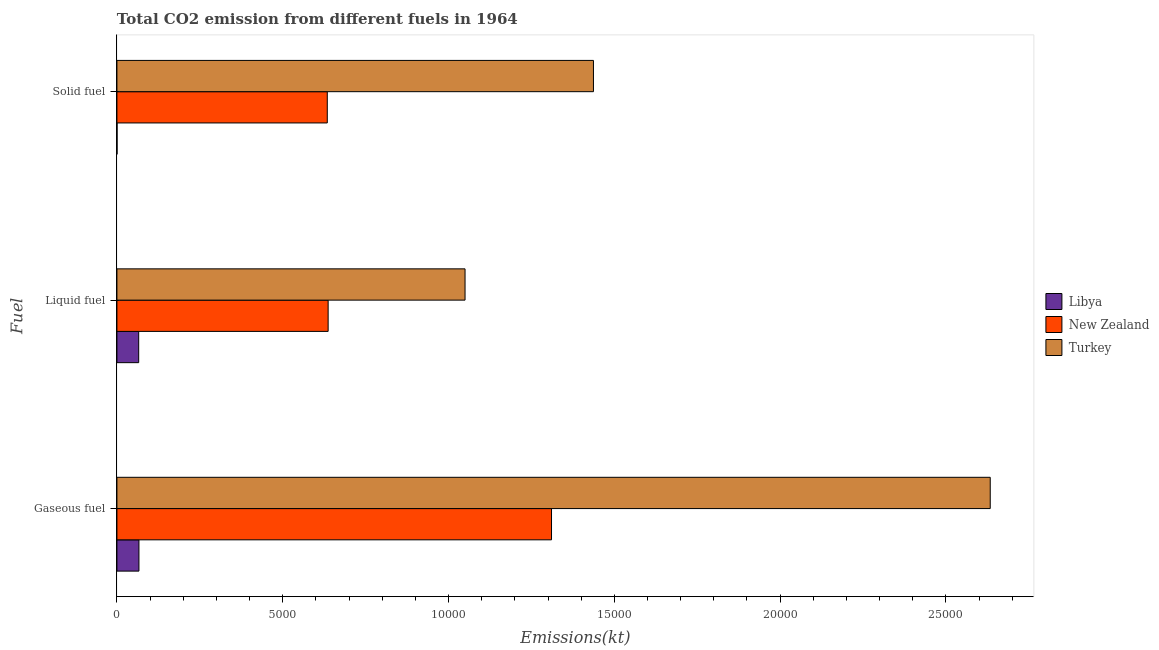Are the number of bars per tick equal to the number of legend labels?
Give a very brief answer. Yes. Are the number of bars on each tick of the Y-axis equal?
Make the answer very short. Yes. What is the label of the 3rd group of bars from the top?
Offer a very short reply. Gaseous fuel. What is the amount of co2 emissions from gaseous fuel in New Zealand?
Your response must be concise. 1.31e+04. Across all countries, what is the maximum amount of co2 emissions from gaseous fuel?
Ensure brevity in your answer.  2.63e+04. Across all countries, what is the minimum amount of co2 emissions from gaseous fuel?
Offer a terse response. 663.73. In which country was the amount of co2 emissions from solid fuel minimum?
Make the answer very short. Libya. What is the total amount of co2 emissions from solid fuel in the graph?
Your response must be concise. 2.07e+04. What is the difference between the amount of co2 emissions from liquid fuel in New Zealand and that in Libya?
Provide a succinct answer. 5713.19. What is the difference between the amount of co2 emissions from liquid fuel in Turkey and the amount of co2 emissions from gaseous fuel in New Zealand?
Offer a very short reply. -2607.24. What is the average amount of co2 emissions from gaseous fuel per country?
Keep it short and to the point. 1.34e+04. What is the difference between the amount of co2 emissions from liquid fuel and amount of co2 emissions from solid fuel in New Zealand?
Your answer should be very brief. 25.67. What is the ratio of the amount of co2 emissions from solid fuel in Turkey to that in New Zealand?
Provide a succinct answer. 2.27. Is the amount of co2 emissions from liquid fuel in New Zealand less than that in Turkey?
Ensure brevity in your answer.  Yes. Is the difference between the amount of co2 emissions from solid fuel in Turkey and New Zealand greater than the difference between the amount of co2 emissions from gaseous fuel in Turkey and New Zealand?
Provide a succinct answer. No. What is the difference between the highest and the second highest amount of co2 emissions from gaseous fuel?
Your answer should be compact. 1.32e+04. What is the difference between the highest and the lowest amount of co2 emissions from liquid fuel?
Provide a succinct answer. 9842.23. In how many countries, is the amount of co2 emissions from solid fuel greater than the average amount of co2 emissions from solid fuel taken over all countries?
Offer a very short reply. 1. Is the sum of the amount of co2 emissions from liquid fuel in New Zealand and Turkey greater than the maximum amount of co2 emissions from gaseous fuel across all countries?
Ensure brevity in your answer.  No. What does the 1st bar from the top in Liquid fuel represents?
Your answer should be very brief. Turkey. What does the 1st bar from the bottom in Solid fuel represents?
Offer a very short reply. Libya. Is it the case that in every country, the sum of the amount of co2 emissions from gaseous fuel and amount of co2 emissions from liquid fuel is greater than the amount of co2 emissions from solid fuel?
Offer a very short reply. Yes. How many bars are there?
Make the answer very short. 9. What is the difference between two consecutive major ticks on the X-axis?
Offer a very short reply. 5000. Does the graph contain any zero values?
Your response must be concise. No. How are the legend labels stacked?
Your response must be concise. Vertical. What is the title of the graph?
Give a very brief answer. Total CO2 emission from different fuels in 1964. Does "Australia" appear as one of the legend labels in the graph?
Offer a very short reply. No. What is the label or title of the X-axis?
Offer a very short reply. Emissions(kt). What is the label or title of the Y-axis?
Your response must be concise. Fuel. What is the Emissions(kt) in Libya in Gaseous fuel?
Provide a succinct answer. 663.73. What is the Emissions(kt) in New Zealand in Gaseous fuel?
Offer a very short reply. 1.31e+04. What is the Emissions(kt) of Turkey in Gaseous fuel?
Ensure brevity in your answer.  2.63e+04. What is the Emissions(kt) in Libya in Liquid fuel?
Offer a terse response. 656.39. What is the Emissions(kt) of New Zealand in Liquid fuel?
Your response must be concise. 6369.58. What is the Emissions(kt) of Turkey in Liquid fuel?
Keep it short and to the point. 1.05e+04. What is the Emissions(kt) in Libya in Solid fuel?
Your response must be concise. 3.67. What is the Emissions(kt) in New Zealand in Solid fuel?
Your answer should be very brief. 6343.91. What is the Emissions(kt) in Turkey in Solid fuel?
Ensure brevity in your answer.  1.44e+04. Across all Fuel, what is the maximum Emissions(kt) of Libya?
Give a very brief answer. 663.73. Across all Fuel, what is the maximum Emissions(kt) of New Zealand?
Your answer should be compact. 1.31e+04. Across all Fuel, what is the maximum Emissions(kt) in Turkey?
Provide a short and direct response. 2.63e+04. Across all Fuel, what is the minimum Emissions(kt) in Libya?
Ensure brevity in your answer.  3.67. Across all Fuel, what is the minimum Emissions(kt) of New Zealand?
Make the answer very short. 6343.91. Across all Fuel, what is the minimum Emissions(kt) in Turkey?
Ensure brevity in your answer.  1.05e+04. What is the total Emissions(kt) of Libya in the graph?
Make the answer very short. 1323.79. What is the total Emissions(kt) in New Zealand in the graph?
Your answer should be very brief. 2.58e+04. What is the total Emissions(kt) in Turkey in the graph?
Offer a very short reply. 5.12e+04. What is the difference between the Emissions(kt) of Libya in Gaseous fuel and that in Liquid fuel?
Ensure brevity in your answer.  7.33. What is the difference between the Emissions(kt) in New Zealand in Gaseous fuel and that in Liquid fuel?
Your response must be concise. 6736.28. What is the difference between the Emissions(kt) of Turkey in Gaseous fuel and that in Liquid fuel?
Your answer should be compact. 1.58e+04. What is the difference between the Emissions(kt) of Libya in Gaseous fuel and that in Solid fuel?
Keep it short and to the point. 660.06. What is the difference between the Emissions(kt) in New Zealand in Gaseous fuel and that in Solid fuel?
Ensure brevity in your answer.  6761.95. What is the difference between the Emissions(kt) of Turkey in Gaseous fuel and that in Solid fuel?
Ensure brevity in your answer.  1.20e+04. What is the difference between the Emissions(kt) of Libya in Liquid fuel and that in Solid fuel?
Offer a very short reply. 652.73. What is the difference between the Emissions(kt) of New Zealand in Liquid fuel and that in Solid fuel?
Your answer should be compact. 25.67. What is the difference between the Emissions(kt) in Turkey in Liquid fuel and that in Solid fuel?
Provide a short and direct response. -3872.35. What is the difference between the Emissions(kt) in Libya in Gaseous fuel and the Emissions(kt) in New Zealand in Liquid fuel?
Your response must be concise. -5705.85. What is the difference between the Emissions(kt) in Libya in Gaseous fuel and the Emissions(kt) in Turkey in Liquid fuel?
Your answer should be very brief. -9834.89. What is the difference between the Emissions(kt) in New Zealand in Gaseous fuel and the Emissions(kt) in Turkey in Liquid fuel?
Offer a very short reply. 2607.24. What is the difference between the Emissions(kt) of Libya in Gaseous fuel and the Emissions(kt) of New Zealand in Solid fuel?
Make the answer very short. -5680.18. What is the difference between the Emissions(kt) in Libya in Gaseous fuel and the Emissions(kt) in Turkey in Solid fuel?
Offer a terse response. -1.37e+04. What is the difference between the Emissions(kt) of New Zealand in Gaseous fuel and the Emissions(kt) of Turkey in Solid fuel?
Keep it short and to the point. -1265.12. What is the difference between the Emissions(kt) of Libya in Liquid fuel and the Emissions(kt) of New Zealand in Solid fuel?
Give a very brief answer. -5687.52. What is the difference between the Emissions(kt) in Libya in Liquid fuel and the Emissions(kt) in Turkey in Solid fuel?
Offer a very short reply. -1.37e+04. What is the difference between the Emissions(kt) of New Zealand in Liquid fuel and the Emissions(kt) of Turkey in Solid fuel?
Provide a short and direct response. -8001.39. What is the average Emissions(kt) of Libya per Fuel?
Your answer should be compact. 441.26. What is the average Emissions(kt) in New Zealand per Fuel?
Your answer should be very brief. 8606.45. What is the average Emissions(kt) in Turkey per Fuel?
Your answer should be compact. 1.71e+04. What is the difference between the Emissions(kt) of Libya and Emissions(kt) of New Zealand in Gaseous fuel?
Make the answer very short. -1.24e+04. What is the difference between the Emissions(kt) of Libya and Emissions(kt) of Turkey in Gaseous fuel?
Offer a very short reply. -2.57e+04. What is the difference between the Emissions(kt) in New Zealand and Emissions(kt) in Turkey in Gaseous fuel?
Keep it short and to the point. -1.32e+04. What is the difference between the Emissions(kt) in Libya and Emissions(kt) in New Zealand in Liquid fuel?
Ensure brevity in your answer.  -5713.19. What is the difference between the Emissions(kt) of Libya and Emissions(kt) of Turkey in Liquid fuel?
Your response must be concise. -9842.23. What is the difference between the Emissions(kt) in New Zealand and Emissions(kt) in Turkey in Liquid fuel?
Your answer should be very brief. -4129.04. What is the difference between the Emissions(kt) of Libya and Emissions(kt) of New Zealand in Solid fuel?
Provide a short and direct response. -6340.24. What is the difference between the Emissions(kt) in Libya and Emissions(kt) in Turkey in Solid fuel?
Offer a very short reply. -1.44e+04. What is the difference between the Emissions(kt) of New Zealand and Emissions(kt) of Turkey in Solid fuel?
Your answer should be compact. -8027.06. What is the ratio of the Emissions(kt) in Libya in Gaseous fuel to that in Liquid fuel?
Ensure brevity in your answer.  1.01. What is the ratio of the Emissions(kt) in New Zealand in Gaseous fuel to that in Liquid fuel?
Provide a succinct answer. 2.06. What is the ratio of the Emissions(kt) of Turkey in Gaseous fuel to that in Liquid fuel?
Offer a terse response. 2.51. What is the ratio of the Emissions(kt) in Libya in Gaseous fuel to that in Solid fuel?
Offer a terse response. 181. What is the ratio of the Emissions(kt) in New Zealand in Gaseous fuel to that in Solid fuel?
Make the answer very short. 2.07. What is the ratio of the Emissions(kt) of Turkey in Gaseous fuel to that in Solid fuel?
Your response must be concise. 1.83. What is the ratio of the Emissions(kt) in Libya in Liquid fuel to that in Solid fuel?
Your answer should be compact. 179. What is the ratio of the Emissions(kt) of New Zealand in Liquid fuel to that in Solid fuel?
Offer a terse response. 1. What is the ratio of the Emissions(kt) in Turkey in Liquid fuel to that in Solid fuel?
Your answer should be very brief. 0.73. What is the difference between the highest and the second highest Emissions(kt) in Libya?
Offer a terse response. 7.33. What is the difference between the highest and the second highest Emissions(kt) in New Zealand?
Make the answer very short. 6736.28. What is the difference between the highest and the second highest Emissions(kt) of Turkey?
Give a very brief answer. 1.20e+04. What is the difference between the highest and the lowest Emissions(kt) in Libya?
Offer a very short reply. 660.06. What is the difference between the highest and the lowest Emissions(kt) in New Zealand?
Your answer should be very brief. 6761.95. What is the difference between the highest and the lowest Emissions(kt) in Turkey?
Ensure brevity in your answer.  1.58e+04. 